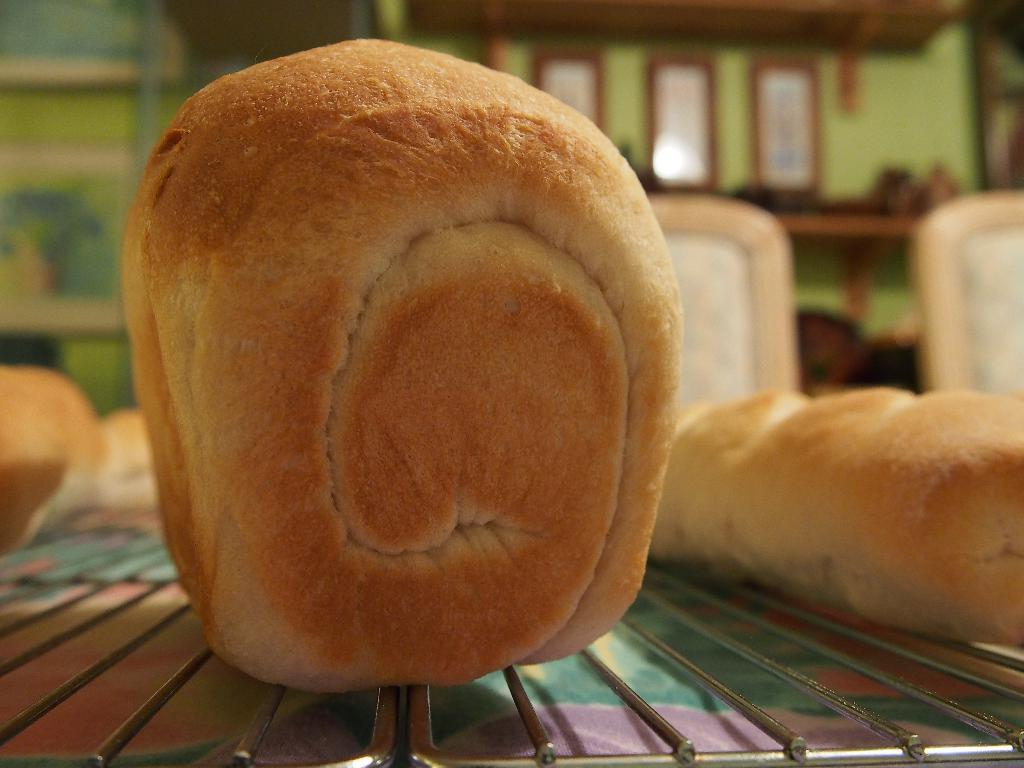What is being cooked on the grill in the image? There are baked buns on the grill in the image. What can be seen in the background of the image? The background of the image includes a green color wall. Are there any decorative elements on the wall in the background? Yes, there are frames on the wall in the background of the image. How much money is being exchanged in the image? There is no indication of money being exchanged in the image; it features baked buns on a grill and a green wall with frames in the background. 